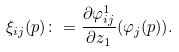<formula> <loc_0><loc_0><loc_500><loc_500>\xi _ { i j } ( p ) \colon = \frac { \partial \varphi _ { i j } ^ { 1 } } { \partial z _ { 1 } } ( \varphi _ { j } ( p ) ) .</formula> 